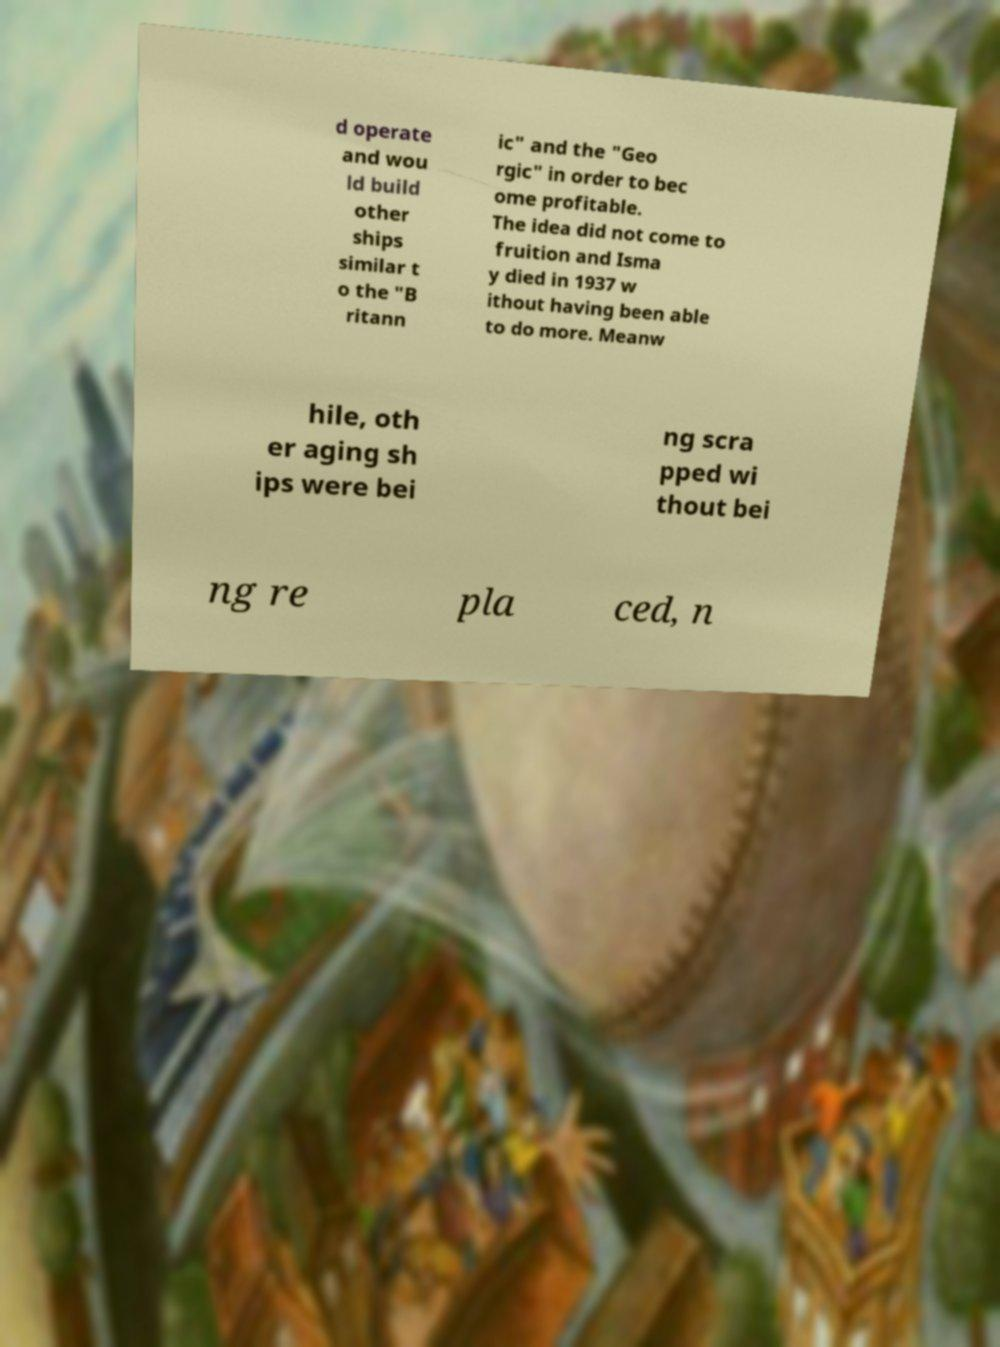For documentation purposes, I need the text within this image transcribed. Could you provide that? d operate and wou ld build other ships similar t o the "B ritann ic" and the "Geo rgic" in order to bec ome profitable. The idea did not come to fruition and Isma y died in 1937 w ithout having been able to do more. Meanw hile, oth er aging sh ips were bei ng scra pped wi thout bei ng re pla ced, n 